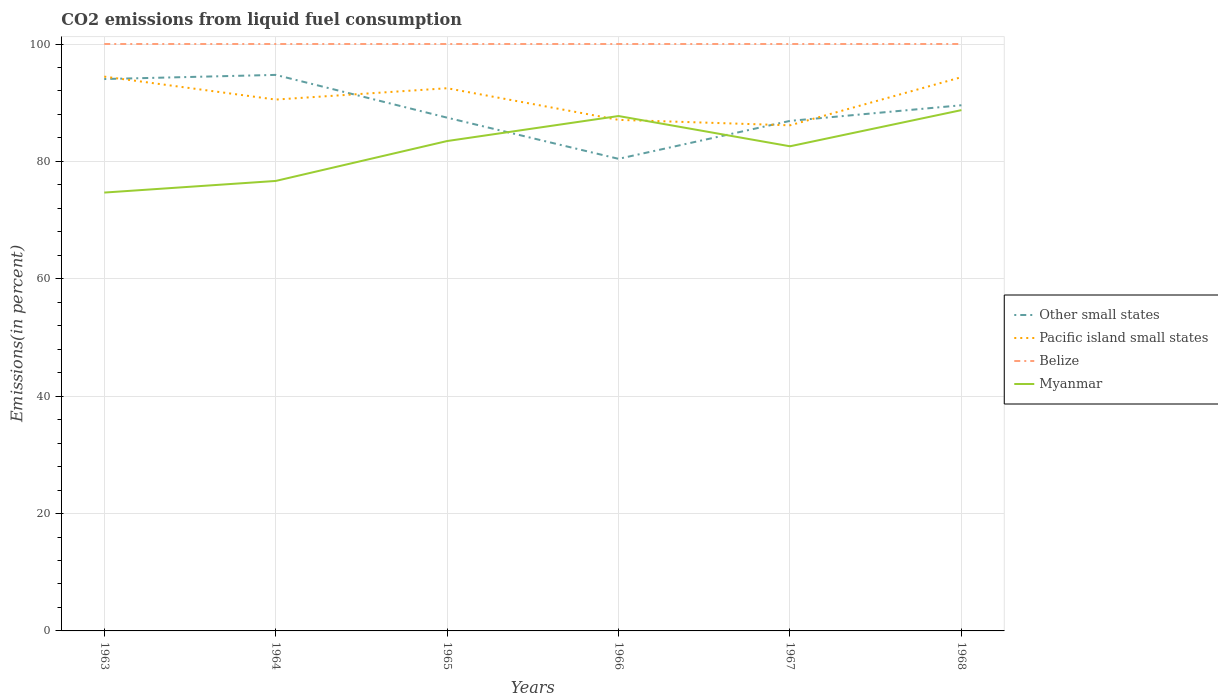Does the line corresponding to Belize intersect with the line corresponding to Other small states?
Keep it short and to the point. No. Across all years, what is the maximum total CO2 emitted in Belize?
Your response must be concise. 100. In which year was the total CO2 emitted in Other small states maximum?
Give a very brief answer. 1966. What is the total total CO2 emitted in Myanmar in the graph?
Your answer should be very brief. -6.8. What is the difference between the highest and the second highest total CO2 emitted in Myanmar?
Your response must be concise. 14.05. What is the difference between the highest and the lowest total CO2 emitted in Other small states?
Offer a very short reply. 3. Is the total CO2 emitted in Other small states strictly greater than the total CO2 emitted in Belize over the years?
Your response must be concise. Yes. How many lines are there?
Your answer should be very brief. 4. How many years are there in the graph?
Provide a short and direct response. 6. Does the graph contain grids?
Your answer should be compact. Yes. Where does the legend appear in the graph?
Your answer should be compact. Center right. How many legend labels are there?
Offer a very short reply. 4. How are the legend labels stacked?
Keep it short and to the point. Vertical. What is the title of the graph?
Your response must be concise. CO2 emissions from liquid fuel consumption. Does "Bahrain" appear as one of the legend labels in the graph?
Give a very brief answer. No. What is the label or title of the Y-axis?
Provide a short and direct response. Emissions(in percent). What is the Emissions(in percent) of Other small states in 1963?
Offer a very short reply. 94.03. What is the Emissions(in percent) of Pacific island small states in 1963?
Your response must be concise. 94.44. What is the Emissions(in percent) of Myanmar in 1963?
Make the answer very short. 74.69. What is the Emissions(in percent) of Other small states in 1964?
Provide a succinct answer. 94.74. What is the Emissions(in percent) in Pacific island small states in 1964?
Your response must be concise. 90.53. What is the Emissions(in percent) of Myanmar in 1964?
Provide a short and direct response. 76.67. What is the Emissions(in percent) of Other small states in 1965?
Your answer should be very brief. 87.45. What is the Emissions(in percent) in Pacific island small states in 1965?
Offer a very short reply. 92.47. What is the Emissions(in percent) of Myanmar in 1965?
Give a very brief answer. 83.47. What is the Emissions(in percent) in Other small states in 1966?
Your answer should be compact. 80.43. What is the Emissions(in percent) in Pacific island small states in 1966?
Offer a very short reply. 87.07. What is the Emissions(in percent) of Myanmar in 1966?
Offer a very short reply. 87.73. What is the Emissions(in percent) of Other small states in 1967?
Make the answer very short. 86.9. What is the Emissions(in percent) in Pacific island small states in 1967?
Your answer should be compact. 86.14. What is the Emissions(in percent) of Myanmar in 1967?
Ensure brevity in your answer.  82.57. What is the Emissions(in percent) in Other small states in 1968?
Provide a succinct answer. 89.56. What is the Emissions(in percent) in Pacific island small states in 1968?
Provide a succinct answer. 94.35. What is the Emissions(in percent) in Myanmar in 1968?
Your answer should be compact. 88.74. Across all years, what is the maximum Emissions(in percent) in Other small states?
Give a very brief answer. 94.74. Across all years, what is the maximum Emissions(in percent) of Pacific island small states?
Offer a terse response. 94.44. Across all years, what is the maximum Emissions(in percent) of Myanmar?
Offer a terse response. 88.74. Across all years, what is the minimum Emissions(in percent) of Other small states?
Provide a short and direct response. 80.43. Across all years, what is the minimum Emissions(in percent) of Pacific island small states?
Ensure brevity in your answer.  86.14. Across all years, what is the minimum Emissions(in percent) in Myanmar?
Keep it short and to the point. 74.69. What is the total Emissions(in percent) of Other small states in the graph?
Offer a terse response. 533.12. What is the total Emissions(in percent) of Pacific island small states in the graph?
Provide a succinct answer. 545.01. What is the total Emissions(in percent) of Belize in the graph?
Provide a short and direct response. 600. What is the total Emissions(in percent) in Myanmar in the graph?
Give a very brief answer. 493.86. What is the difference between the Emissions(in percent) of Other small states in 1963 and that in 1964?
Offer a very short reply. -0.71. What is the difference between the Emissions(in percent) in Pacific island small states in 1963 and that in 1964?
Offer a terse response. 3.91. What is the difference between the Emissions(in percent) in Belize in 1963 and that in 1964?
Provide a succinct answer. 0. What is the difference between the Emissions(in percent) of Myanmar in 1963 and that in 1964?
Provide a succinct answer. -1.98. What is the difference between the Emissions(in percent) in Other small states in 1963 and that in 1965?
Your answer should be compact. 6.58. What is the difference between the Emissions(in percent) in Pacific island small states in 1963 and that in 1965?
Your answer should be very brief. 1.98. What is the difference between the Emissions(in percent) of Myanmar in 1963 and that in 1965?
Provide a succinct answer. -8.78. What is the difference between the Emissions(in percent) of Other small states in 1963 and that in 1966?
Offer a terse response. 13.6. What is the difference between the Emissions(in percent) in Pacific island small states in 1963 and that in 1966?
Provide a succinct answer. 7.37. What is the difference between the Emissions(in percent) of Myanmar in 1963 and that in 1966?
Give a very brief answer. -13.04. What is the difference between the Emissions(in percent) in Other small states in 1963 and that in 1967?
Keep it short and to the point. 7.13. What is the difference between the Emissions(in percent) in Pacific island small states in 1963 and that in 1967?
Make the answer very short. 8.3. What is the difference between the Emissions(in percent) of Myanmar in 1963 and that in 1967?
Make the answer very short. -7.89. What is the difference between the Emissions(in percent) in Other small states in 1963 and that in 1968?
Your answer should be very brief. 4.47. What is the difference between the Emissions(in percent) of Pacific island small states in 1963 and that in 1968?
Offer a very short reply. 0.09. What is the difference between the Emissions(in percent) in Myanmar in 1963 and that in 1968?
Keep it short and to the point. -14.05. What is the difference between the Emissions(in percent) of Other small states in 1964 and that in 1965?
Offer a terse response. 7.29. What is the difference between the Emissions(in percent) of Pacific island small states in 1964 and that in 1965?
Your answer should be compact. -1.93. What is the difference between the Emissions(in percent) of Belize in 1964 and that in 1965?
Offer a terse response. 0. What is the difference between the Emissions(in percent) in Myanmar in 1964 and that in 1965?
Provide a short and direct response. -6.8. What is the difference between the Emissions(in percent) of Other small states in 1964 and that in 1966?
Your answer should be very brief. 14.3. What is the difference between the Emissions(in percent) of Pacific island small states in 1964 and that in 1966?
Offer a terse response. 3.46. What is the difference between the Emissions(in percent) of Belize in 1964 and that in 1966?
Provide a short and direct response. 0. What is the difference between the Emissions(in percent) of Myanmar in 1964 and that in 1966?
Provide a succinct answer. -11.06. What is the difference between the Emissions(in percent) in Other small states in 1964 and that in 1967?
Provide a short and direct response. 7.84. What is the difference between the Emissions(in percent) in Pacific island small states in 1964 and that in 1967?
Your answer should be compact. 4.39. What is the difference between the Emissions(in percent) of Belize in 1964 and that in 1967?
Offer a very short reply. 0. What is the difference between the Emissions(in percent) in Myanmar in 1964 and that in 1967?
Offer a terse response. -5.91. What is the difference between the Emissions(in percent) in Other small states in 1964 and that in 1968?
Keep it short and to the point. 5.17. What is the difference between the Emissions(in percent) in Pacific island small states in 1964 and that in 1968?
Give a very brief answer. -3.82. What is the difference between the Emissions(in percent) in Myanmar in 1964 and that in 1968?
Keep it short and to the point. -12.07. What is the difference between the Emissions(in percent) of Other small states in 1965 and that in 1966?
Provide a succinct answer. 7.01. What is the difference between the Emissions(in percent) in Pacific island small states in 1965 and that in 1966?
Your response must be concise. 5.39. What is the difference between the Emissions(in percent) of Belize in 1965 and that in 1966?
Provide a succinct answer. 0. What is the difference between the Emissions(in percent) of Myanmar in 1965 and that in 1966?
Offer a very short reply. -4.26. What is the difference between the Emissions(in percent) of Other small states in 1965 and that in 1967?
Offer a terse response. 0.55. What is the difference between the Emissions(in percent) in Pacific island small states in 1965 and that in 1967?
Provide a short and direct response. 6.32. What is the difference between the Emissions(in percent) of Belize in 1965 and that in 1967?
Your answer should be compact. 0. What is the difference between the Emissions(in percent) in Myanmar in 1965 and that in 1967?
Keep it short and to the point. 0.89. What is the difference between the Emissions(in percent) in Other small states in 1965 and that in 1968?
Ensure brevity in your answer.  -2.11. What is the difference between the Emissions(in percent) in Pacific island small states in 1965 and that in 1968?
Make the answer very short. -1.88. What is the difference between the Emissions(in percent) of Myanmar in 1965 and that in 1968?
Provide a succinct answer. -5.27. What is the difference between the Emissions(in percent) in Other small states in 1966 and that in 1967?
Your answer should be compact. -6.47. What is the difference between the Emissions(in percent) in Pacific island small states in 1966 and that in 1967?
Give a very brief answer. 0.93. What is the difference between the Emissions(in percent) in Belize in 1966 and that in 1967?
Give a very brief answer. 0. What is the difference between the Emissions(in percent) of Myanmar in 1966 and that in 1967?
Provide a short and direct response. 5.16. What is the difference between the Emissions(in percent) of Other small states in 1966 and that in 1968?
Your answer should be very brief. -9.13. What is the difference between the Emissions(in percent) in Pacific island small states in 1966 and that in 1968?
Offer a very short reply. -7.28. What is the difference between the Emissions(in percent) of Myanmar in 1966 and that in 1968?
Your response must be concise. -1.01. What is the difference between the Emissions(in percent) of Other small states in 1967 and that in 1968?
Offer a very short reply. -2.66. What is the difference between the Emissions(in percent) in Pacific island small states in 1967 and that in 1968?
Keep it short and to the point. -8.21. What is the difference between the Emissions(in percent) of Myanmar in 1967 and that in 1968?
Make the answer very short. -6.16. What is the difference between the Emissions(in percent) of Other small states in 1963 and the Emissions(in percent) of Pacific island small states in 1964?
Give a very brief answer. 3.5. What is the difference between the Emissions(in percent) in Other small states in 1963 and the Emissions(in percent) in Belize in 1964?
Your answer should be compact. -5.97. What is the difference between the Emissions(in percent) in Other small states in 1963 and the Emissions(in percent) in Myanmar in 1964?
Give a very brief answer. 17.36. What is the difference between the Emissions(in percent) of Pacific island small states in 1963 and the Emissions(in percent) of Belize in 1964?
Provide a succinct answer. -5.56. What is the difference between the Emissions(in percent) of Pacific island small states in 1963 and the Emissions(in percent) of Myanmar in 1964?
Ensure brevity in your answer.  17.78. What is the difference between the Emissions(in percent) of Belize in 1963 and the Emissions(in percent) of Myanmar in 1964?
Offer a very short reply. 23.33. What is the difference between the Emissions(in percent) in Other small states in 1963 and the Emissions(in percent) in Pacific island small states in 1965?
Give a very brief answer. 1.56. What is the difference between the Emissions(in percent) in Other small states in 1963 and the Emissions(in percent) in Belize in 1965?
Provide a succinct answer. -5.97. What is the difference between the Emissions(in percent) in Other small states in 1963 and the Emissions(in percent) in Myanmar in 1965?
Make the answer very short. 10.56. What is the difference between the Emissions(in percent) of Pacific island small states in 1963 and the Emissions(in percent) of Belize in 1965?
Your answer should be very brief. -5.56. What is the difference between the Emissions(in percent) of Pacific island small states in 1963 and the Emissions(in percent) of Myanmar in 1965?
Offer a terse response. 10.98. What is the difference between the Emissions(in percent) of Belize in 1963 and the Emissions(in percent) of Myanmar in 1965?
Your response must be concise. 16.53. What is the difference between the Emissions(in percent) in Other small states in 1963 and the Emissions(in percent) in Pacific island small states in 1966?
Provide a succinct answer. 6.96. What is the difference between the Emissions(in percent) of Other small states in 1963 and the Emissions(in percent) of Belize in 1966?
Your answer should be very brief. -5.97. What is the difference between the Emissions(in percent) of Other small states in 1963 and the Emissions(in percent) of Myanmar in 1966?
Make the answer very short. 6.3. What is the difference between the Emissions(in percent) in Pacific island small states in 1963 and the Emissions(in percent) in Belize in 1966?
Make the answer very short. -5.56. What is the difference between the Emissions(in percent) of Pacific island small states in 1963 and the Emissions(in percent) of Myanmar in 1966?
Keep it short and to the point. 6.72. What is the difference between the Emissions(in percent) in Belize in 1963 and the Emissions(in percent) in Myanmar in 1966?
Your answer should be compact. 12.27. What is the difference between the Emissions(in percent) of Other small states in 1963 and the Emissions(in percent) of Pacific island small states in 1967?
Make the answer very short. 7.89. What is the difference between the Emissions(in percent) in Other small states in 1963 and the Emissions(in percent) in Belize in 1967?
Provide a short and direct response. -5.97. What is the difference between the Emissions(in percent) in Other small states in 1963 and the Emissions(in percent) in Myanmar in 1967?
Provide a short and direct response. 11.46. What is the difference between the Emissions(in percent) of Pacific island small states in 1963 and the Emissions(in percent) of Belize in 1967?
Offer a terse response. -5.56. What is the difference between the Emissions(in percent) of Pacific island small states in 1963 and the Emissions(in percent) of Myanmar in 1967?
Your response must be concise. 11.87. What is the difference between the Emissions(in percent) in Belize in 1963 and the Emissions(in percent) in Myanmar in 1967?
Provide a short and direct response. 17.43. What is the difference between the Emissions(in percent) in Other small states in 1963 and the Emissions(in percent) in Pacific island small states in 1968?
Offer a very short reply. -0.32. What is the difference between the Emissions(in percent) in Other small states in 1963 and the Emissions(in percent) in Belize in 1968?
Your response must be concise. -5.97. What is the difference between the Emissions(in percent) in Other small states in 1963 and the Emissions(in percent) in Myanmar in 1968?
Provide a short and direct response. 5.29. What is the difference between the Emissions(in percent) in Pacific island small states in 1963 and the Emissions(in percent) in Belize in 1968?
Keep it short and to the point. -5.56. What is the difference between the Emissions(in percent) of Pacific island small states in 1963 and the Emissions(in percent) of Myanmar in 1968?
Provide a short and direct response. 5.71. What is the difference between the Emissions(in percent) of Belize in 1963 and the Emissions(in percent) of Myanmar in 1968?
Your answer should be very brief. 11.26. What is the difference between the Emissions(in percent) of Other small states in 1964 and the Emissions(in percent) of Pacific island small states in 1965?
Your response must be concise. 2.27. What is the difference between the Emissions(in percent) of Other small states in 1964 and the Emissions(in percent) of Belize in 1965?
Keep it short and to the point. -5.26. What is the difference between the Emissions(in percent) in Other small states in 1964 and the Emissions(in percent) in Myanmar in 1965?
Your answer should be compact. 11.27. What is the difference between the Emissions(in percent) in Pacific island small states in 1964 and the Emissions(in percent) in Belize in 1965?
Offer a terse response. -9.47. What is the difference between the Emissions(in percent) of Pacific island small states in 1964 and the Emissions(in percent) of Myanmar in 1965?
Offer a terse response. 7.06. What is the difference between the Emissions(in percent) in Belize in 1964 and the Emissions(in percent) in Myanmar in 1965?
Offer a terse response. 16.53. What is the difference between the Emissions(in percent) in Other small states in 1964 and the Emissions(in percent) in Pacific island small states in 1966?
Make the answer very short. 7.66. What is the difference between the Emissions(in percent) of Other small states in 1964 and the Emissions(in percent) of Belize in 1966?
Your answer should be very brief. -5.26. What is the difference between the Emissions(in percent) of Other small states in 1964 and the Emissions(in percent) of Myanmar in 1966?
Make the answer very short. 7.01. What is the difference between the Emissions(in percent) of Pacific island small states in 1964 and the Emissions(in percent) of Belize in 1966?
Provide a short and direct response. -9.47. What is the difference between the Emissions(in percent) in Pacific island small states in 1964 and the Emissions(in percent) in Myanmar in 1966?
Ensure brevity in your answer.  2.8. What is the difference between the Emissions(in percent) of Belize in 1964 and the Emissions(in percent) of Myanmar in 1966?
Keep it short and to the point. 12.27. What is the difference between the Emissions(in percent) of Other small states in 1964 and the Emissions(in percent) of Pacific island small states in 1967?
Offer a very short reply. 8.59. What is the difference between the Emissions(in percent) in Other small states in 1964 and the Emissions(in percent) in Belize in 1967?
Keep it short and to the point. -5.26. What is the difference between the Emissions(in percent) in Other small states in 1964 and the Emissions(in percent) in Myanmar in 1967?
Your answer should be very brief. 12.16. What is the difference between the Emissions(in percent) in Pacific island small states in 1964 and the Emissions(in percent) in Belize in 1967?
Offer a terse response. -9.47. What is the difference between the Emissions(in percent) in Pacific island small states in 1964 and the Emissions(in percent) in Myanmar in 1967?
Ensure brevity in your answer.  7.96. What is the difference between the Emissions(in percent) in Belize in 1964 and the Emissions(in percent) in Myanmar in 1967?
Keep it short and to the point. 17.43. What is the difference between the Emissions(in percent) in Other small states in 1964 and the Emissions(in percent) in Pacific island small states in 1968?
Keep it short and to the point. 0.39. What is the difference between the Emissions(in percent) of Other small states in 1964 and the Emissions(in percent) of Belize in 1968?
Your answer should be very brief. -5.26. What is the difference between the Emissions(in percent) in Other small states in 1964 and the Emissions(in percent) in Myanmar in 1968?
Make the answer very short. 6. What is the difference between the Emissions(in percent) in Pacific island small states in 1964 and the Emissions(in percent) in Belize in 1968?
Your answer should be very brief. -9.47. What is the difference between the Emissions(in percent) in Pacific island small states in 1964 and the Emissions(in percent) in Myanmar in 1968?
Your answer should be compact. 1.8. What is the difference between the Emissions(in percent) of Belize in 1964 and the Emissions(in percent) of Myanmar in 1968?
Offer a terse response. 11.26. What is the difference between the Emissions(in percent) of Other small states in 1965 and the Emissions(in percent) of Pacific island small states in 1966?
Ensure brevity in your answer.  0.37. What is the difference between the Emissions(in percent) of Other small states in 1965 and the Emissions(in percent) of Belize in 1966?
Offer a terse response. -12.55. What is the difference between the Emissions(in percent) of Other small states in 1965 and the Emissions(in percent) of Myanmar in 1966?
Provide a succinct answer. -0.28. What is the difference between the Emissions(in percent) in Pacific island small states in 1965 and the Emissions(in percent) in Belize in 1966?
Offer a terse response. -7.53. What is the difference between the Emissions(in percent) in Pacific island small states in 1965 and the Emissions(in percent) in Myanmar in 1966?
Your response must be concise. 4.74. What is the difference between the Emissions(in percent) of Belize in 1965 and the Emissions(in percent) of Myanmar in 1966?
Your response must be concise. 12.27. What is the difference between the Emissions(in percent) in Other small states in 1965 and the Emissions(in percent) in Pacific island small states in 1967?
Ensure brevity in your answer.  1.3. What is the difference between the Emissions(in percent) in Other small states in 1965 and the Emissions(in percent) in Belize in 1967?
Keep it short and to the point. -12.55. What is the difference between the Emissions(in percent) in Other small states in 1965 and the Emissions(in percent) in Myanmar in 1967?
Give a very brief answer. 4.88. What is the difference between the Emissions(in percent) in Pacific island small states in 1965 and the Emissions(in percent) in Belize in 1967?
Ensure brevity in your answer.  -7.53. What is the difference between the Emissions(in percent) of Pacific island small states in 1965 and the Emissions(in percent) of Myanmar in 1967?
Provide a succinct answer. 9.89. What is the difference between the Emissions(in percent) in Belize in 1965 and the Emissions(in percent) in Myanmar in 1967?
Your answer should be compact. 17.43. What is the difference between the Emissions(in percent) in Other small states in 1965 and the Emissions(in percent) in Pacific island small states in 1968?
Your response must be concise. -6.9. What is the difference between the Emissions(in percent) of Other small states in 1965 and the Emissions(in percent) of Belize in 1968?
Provide a short and direct response. -12.55. What is the difference between the Emissions(in percent) in Other small states in 1965 and the Emissions(in percent) in Myanmar in 1968?
Provide a short and direct response. -1.29. What is the difference between the Emissions(in percent) of Pacific island small states in 1965 and the Emissions(in percent) of Belize in 1968?
Your answer should be compact. -7.53. What is the difference between the Emissions(in percent) of Pacific island small states in 1965 and the Emissions(in percent) of Myanmar in 1968?
Your response must be concise. 3.73. What is the difference between the Emissions(in percent) of Belize in 1965 and the Emissions(in percent) of Myanmar in 1968?
Offer a terse response. 11.26. What is the difference between the Emissions(in percent) of Other small states in 1966 and the Emissions(in percent) of Pacific island small states in 1967?
Offer a terse response. -5.71. What is the difference between the Emissions(in percent) in Other small states in 1966 and the Emissions(in percent) in Belize in 1967?
Make the answer very short. -19.57. What is the difference between the Emissions(in percent) in Other small states in 1966 and the Emissions(in percent) in Myanmar in 1967?
Provide a short and direct response. -2.14. What is the difference between the Emissions(in percent) in Pacific island small states in 1966 and the Emissions(in percent) in Belize in 1967?
Ensure brevity in your answer.  -12.93. What is the difference between the Emissions(in percent) of Pacific island small states in 1966 and the Emissions(in percent) of Myanmar in 1967?
Your answer should be very brief. 4.5. What is the difference between the Emissions(in percent) in Belize in 1966 and the Emissions(in percent) in Myanmar in 1967?
Provide a short and direct response. 17.43. What is the difference between the Emissions(in percent) in Other small states in 1966 and the Emissions(in percent) in Pacific island small states in 1968?
Ensure brevity in your answer.  -13.92. What is the difference between the Emissions(in percent) in Other small states in 1966 and the Emissions(in percent) in Belize in 1968?
Provide a succinct answer. -19.57. What is the difference between the Emissions(in percent) of Other small states in 1966 and the Emissions(in percent) of Myanmar in 1968?
Provide a short and direct response. -8.3. What is the difference between the Emissions(in percent) of Pacific island small states in 1966 and the Emissions(in percent) of Belize in 1968?
Provide a succinct answer. -12.93. What is the difference between the Emissions(in percent) in Pacific island small states in 1966 and the Emissions(in percent) in Myanmar in 1968?
Give a very brief answer. -1.66. What is the difference between the Emissions(in percent) in Belize in 1966 and the Emissions(in percent) in Myanmar in 1968?
Provide a succinct answer. 11.26. What is the difference between the Emissions(in percent) in Other small states in 1967 and the Emissions(in percent) in Pacific island small states in 1968?
Provide a succinct answer. -7.45. What is the difference between the Emissions(in percent) in Other small states in 1967 and the Emissions(in percent) in Belize in 1968?
Your answer should be compact. -13.1. What is the difference between the Emissions(in percent) of Other small states in 1967 and the Emissions(in percent) of Myanmar in 1968?
Ensure brevity in your answer.  -1.84. What is the difference between the Emissions(in percent) in Pacific island small states in 1967 and the Emissions(in percent) in Belize in 1968?
Offer a terse response. -13.86. What is the difference between the Emissions(in percent) of Pacific island small states in 1967 and the Emissions(in percent) of Myanmar in 1968?
Your answer should be compact. -2.59. What is the difference between the Emissions(in percent) of Belize in 1967 and the Emissions(in percent) of Myanmar in 1968?
Provide a short and direct response. 11.26. What is the average Emissions(in percent) of Other small states per year?
Make the answer very short. 88.85. What is the average Emissions(in percent) of Pacific island small states per year?
Make the answer very short. 90.84. What is the average Emissions(in percent) in Belize per year?
Your response must be concise. 100. What is the average Emissions(in percent) of Myanmar per year?
Provide a short and direct response. 82.31. In the year 1963, what is the difference between the Emissions(in percent) of Other small states and Emissions(in percent) of Pacific island small states?
Your response must be concise. -0.41. In the year 1963, what is the difference between the Emissions(in percent) in Other small states and Emissions(in percent) in Belize?
Offer a very short reply. -5.97. In the year 1963, what is the difference between the Emissions(in percent) of Other small states and Emissions(in percent) of Myanmar?
Give a very brief answer. 19.34. In the year 1963, what is the difference between the Emissions(in percent) in Pacific island small states and Emissions(in percent) in Belize?
Offer a terse response. -5.56. In the year 1963, what is the difference between the Emissions(in percent) in Pacific island small states and Emissions(in percent) in Myanmar?
Make the answer very short. 19.76. In the year 1963, what is the difference between the Emissions(in percent) in Belize and Emissions(in percent) in Myanmar?
Your response must be concise. 25.31. In the year 1964, what is the difference between the Emissions(in percent) of Other small states and Emissions(in percent) of Pacific island small states?
Provide a short and direct response. 4.2. In the year 1964, what is the difference between the Emissions(in percent) of Other small states and Emissions(in percent) of Belize?
Provide a short and direct response. -5.26. In the year 1964, what is the difference between the Emissions(in percent) in Other small states and Emissions(in percent) in Myanmar?
Provide a short and direct response. 18.07. In the year 1964, what is the difference between the Emissions(in percent) in Pacific island small states and Emissions(in percent) in Belize?
Give a very brief answer. -9.47. In the year 1964, what is the difference between the Emissions(in percent) in Pacific island small states and Emissions(in percent) in Myanmar?
Your answer should be compact. 13.87. In the year 1964, what is the difference between the Emissions(in percent) of Belize and Emissions(in percent) of Myanmar?
Make the answer very short. 23.33. In the year 1965, what is the difference between the Emissions(in percent) of Other small states and Emissions(in percent) of Pacific island small states?
Your answer should be compact. -5.02. In the year 1965, what is the difference between the Emissions(in percent) of Other small states and Emissions(in percent) of Belize?
Make the answer very short. -12.55. In the year 1965, what is the difference between the Emissions(in percent) in Other small states and Emissions(in percent) in Myanmar?
Keep it short and to the point. 3.98. In the year 1965, what is the difference between the Emissions(in percent) in Pacific island small states and Emissions(in percent) in Belize?
Provide a short and direct response. -7.53. In the year 1965, what is the difference between the Emissions(in percent) of Pacific island small states and Emissions(in percent) of Myanmar?
Ensure brevity in your answer.  9. In the year 1965, what is the difference between the Emissions(in percent) of Belize and Emissions(in percent) of Myanmar?
Offer a very short reply. 16.53. In the year 1966, what is the difference between the Emissions(in percent) of Other small states and Emissions(in percent) of Pacific island small states?
Offer a very short reply. -6.64. In the year 1966, what is the difference between the Emissions(in percent) of Other small states and Emissions(in percent) of Belize?
Offer a terse response. -19.57. In the year 1966, what is the difference between the Emissions(in percent) in Other small states and Emissions(in percent) in Myanmar?
Provide a short and direct response. -7.29. In the year 1966, what is the difference between the Emissions(in percent) of Pacific island small states and Emissions(in percent) of Belize?
Ensure brevity in your answer.  -12.93. In the year 1966, what is the difference between the Emissions(in percent) in Pacific island small states and Emissions(in percent) in Myanmar?
Your answer should be compact. -0.65. In the year 1966, what is the difference between the Emissions(in percent) of Belize and Emissions(in percent) of Myanmar?
Offer a terse response. 12.27. In the year 1967, what is the difference between the Emissions(in percent) in Other small states and Emissions(in percent) in Pacific island small states?
Keep it short and to the point. 0.76. In the year 1967, what is the difference between the Emissions(in percent) in Other small states and Emissions(in percent) in Belize?
Your response must be concise. -13.1. In the year 1967, what is the difference between the Emissions(in percent) of Other small states and Emissions(in percent) of Myanmar?
Provide a short and direct response. 4.33. In the year 1967, what is the difference between the Emissions(in percent) of Pacific island small states and Emissions(in percent) of Belize?
Your answer should be very brief. -13.86. In the year 1967, what is the difference between the Emissions(in percent) of Pacific island small states and Emissions(in percent) of Myanmar?
Make the answer very short. 3.57. In the year 1967, what is the difference between the Emissions(in percent) of Belize and Emissions(in percent) of Myanmar?
Ensure brevity in your answer.  17.43. In the year 1968, what is the difference between the Emissions(in percent) of Other small states and Emissions(in percent) of Pacific island small states?
Your answer should be very brief. -4.79. In the year 1968, what is the difference between the Emissions(in percent) of Other small states and Emissions(in percent) of Belize?
Ensure brevity in your answer.  -10.44. In the year 1968, what is the difference between the Emissions(in percent) of Other small states and Emissions(in percent) of Myanmar?
Provide a short and direct response. 0.83. In the year 1968, what is the difference between the Emissions(in percent) of Pacific island small states and Emissions(in percent) of Belize?
Keep it short and to the point. -5.65. In the year 1968, what is the difference between the Emissions(in percent) of Pacific island small states and Emissions(in percent) of Myanmar?
Offer a very short reply. 5.61. In the year 1968, what is the difference between the Emissions(in percent) of Belize and Emissions(in percent) of Myanmar?
Make the answer very short. 11.26. What is the ratio of the Emissions(in percent) of Pacific island small states in 1963 to that in 1964?
Your answer should be compact. 1.04. What is the ratio of the Emissions(in percent) of Myanmar in 1963 to that in 1964?
Offer a terse response. 0.97. What is the ratio of the Emissions(in percent) of Other small states in 1963 to that in 1965?
Your answer should be very brief. 1.08. What is the ratio of the Emissions(in percent) of Pacific island small states in 1963 to that in 1965?
Provide a short and direct response. 1.02. What is the ratio of the Emissions(in percent) of Myanmar in 1963 to that in 1965?
Provide a short and direct response. 0.89. What is the ratio of the Emissions(in percent) in Other small states in 1963 to that in 1966?
Offer a very short reply. 1.17. What is the ratio of the Emissions(in percent) of Pacific island small states in 1963 to that in 1966?
Ensure brevity in your answer.  1.08. What is the ratio of the Emissions(in percent) of Belize in 1963 to that in 1966?
Offer a terse response. 1. What is the ratio of the Emissions(in percent) of Myanmar in 1963 to that in 1966?
Keep it short and to the point. 0.85. What is the ratio of the Emissions(in percent) of Other small states in 1963 to that in 1967?
Ensure brevity in your answer.  1.08. What is the ratio of the Emissions(in percent) of Pacific island small states in 1963 to that in 1967?
Ensure brevity in your answer.  1.1. What is the ratio of the Emissions(in percent) of Myanmar in 1963 to that in 1967?
Keep it short and to the point. 0.9. What is the ratio of the Emissions(in percent) in Other small states in 1963 to that in 1968?
Offer a terse response. 1.05. What is the ratio of the Emissions(in percent) in Myanmar in 1963 to that in 1968?
Give a very brief answer. 0.84. What is the ratio of the Emissions(in percent) in Other small states in 1964 to that in 1965?
Your answer should be very brief. 1.08. What is the ratio of the Emissions(in percent) in Pacific island small states in 1964 to that in 1965?
Ensure brevity in your answer.  0.98. What is the ratio of the Emissions(in percent) in Myanmar in 1964 to that in 1965?
Make the answer very short. 0.92. What is the ratio of the Emissions(in percent) in Other small states in 1964 to that in 1966?
Your answer should be compact. 1.18. What is the ratio of the Emissions(in percent) in Pacific island small states in 1964 to that in 1966?
Give a very brief answer. 1.04. What is the ratio of the Emissions(in percent) in Myanmar in 1964 to that in 1966?
Offer a terse response. 0.87. What is the ratio of the Emissions(in percent) in Other small states in 1964 to that in 1967?
Your response must be concise. 1.09. What is the ratio of the Emissions(in percent) in Pacific island small states in 1964 to that in 1967?
Provide a succinct answer. 1.05. What is the ratio of the Emissions(in percent) in Myanmar in 1964 to that in 1967?
Give a very brief answer. 0.93. What is the ratio of the Emissions(in percent) of Other small states in 1964 to that in 1968?
Your response must be concise. 1.06. What is the ratio of the Emissions(in percent) in Pacific island small states in 1964 to that in 1968?
Your answer should be compact. 0.96. What is the ratio of the Emissions(in percent) of Belize in 1964 to that in 1968?
Offer a very short reply. 1. What is the ratio of the Emissions(in percent) in Myanmar in 1964 to that in 1968?
Keep it short and to the point. 0.86. What is the ratio of the Emissions(in percent) of Other small states in 1965 to that in 1966?
Keep it short and to the point. 1.09. What is the ratio of the Emissions(in percent) in Pacific island small states in 1965 to that in 1966?
Ensure brevity in your answer.  1.06. What is the ratio of the Emissions(in percent) in Belize in 1965 to that in 1966?
Provide a short and direct response. 1. What is the ratio of the Emissions(in percent) in Myanmar in 1965 to that in 1966?
Make the answer very short. 0.95. What is the ratio of the Emissions(in percent) in Other small states in 1965 to that in 1967?
Keep it short and to the point. 1.01. What is the ratio of the Emissions(in percent) in Pacific island small states in 1965 to that in 1967?
Give a very brief answer. 1.07. What is the ratio of the Emissions(in percent) in Myanmar in 1965 to that in 1967?
Your answer should be very brief. 1.01. What is the ratio of the Emissions(in percent) in Other small states in 1965 to that in 1968?
Offer a very short reply. 0.98. What is the ratio of the Emissions(in percent) in Belize in 1965 to that in 1968?
Keep it short and to the point. 1. What is the ratio of the Emissions(in percent) in Myanmar in 1965 to that in 1968?
Ensure brevity in your answer.  0.94. What is the ratio of the Emissions(in percent) of Other small states in 1966 to that in 1967?
Offer a terse response. 0.93. What is the ratio of the Emissions(in percent) of Pacific island small states in 1966 to that in 1967?
Your response must be concise. 1.01. What is the ratio of the Emissions(in percent) in Myanmar in 1966 to that in 1967?
Offer a very short reply. 1.06. What is the ratio of the Emissions(in percent) of Other small states in 1966 to that in 1968?
Provide a short and direct response. 0.9. What is the ratio of the Emissions(in percent) of Pacific island small states in 1966 to that in 1968?
Ensure brevity in your answer.  0.92. What is the ratio of the Emissions(in percent) in Other small states in 1967 to that in 1968?
Your answer should be very brief. 0.97. What is the ratio of the Emissions(in percent) in Pacific island small states in 1967 to that in 1968?
Ensure brevity in your answer.  0.91. What is the ratio of the Emissions(in percent) of Myanmar in 1967 to that in 1968?
Provide a short and direct response. 0.93. What is the difference between the highest and the second highest Emissions(in percent) of Other small states?
Ensure brevity in your answer.  0.71. What is the difference between the highest and the second highest Emissions(in percent) in Pacific island small states?
Ensure brevity in your answer.  0.09. What is the difference between the highest and the second highest Emissions(in percent) of Myanmar?
Your answer should be very brief. 1.01. What is the difference between the highest and the lowest Emissions(in percent) of Other small states?
Your answer should be very brief. 14.3. What is the difference between the highest and the lowest Emissions(in percent) of Pacific island small states?
Ensure brevity in your answer.  8.3. What is the difference between the highest and the lowest Emissions(in percent) in Myanmar?
Ensure brevity in your answer.  14.05. 